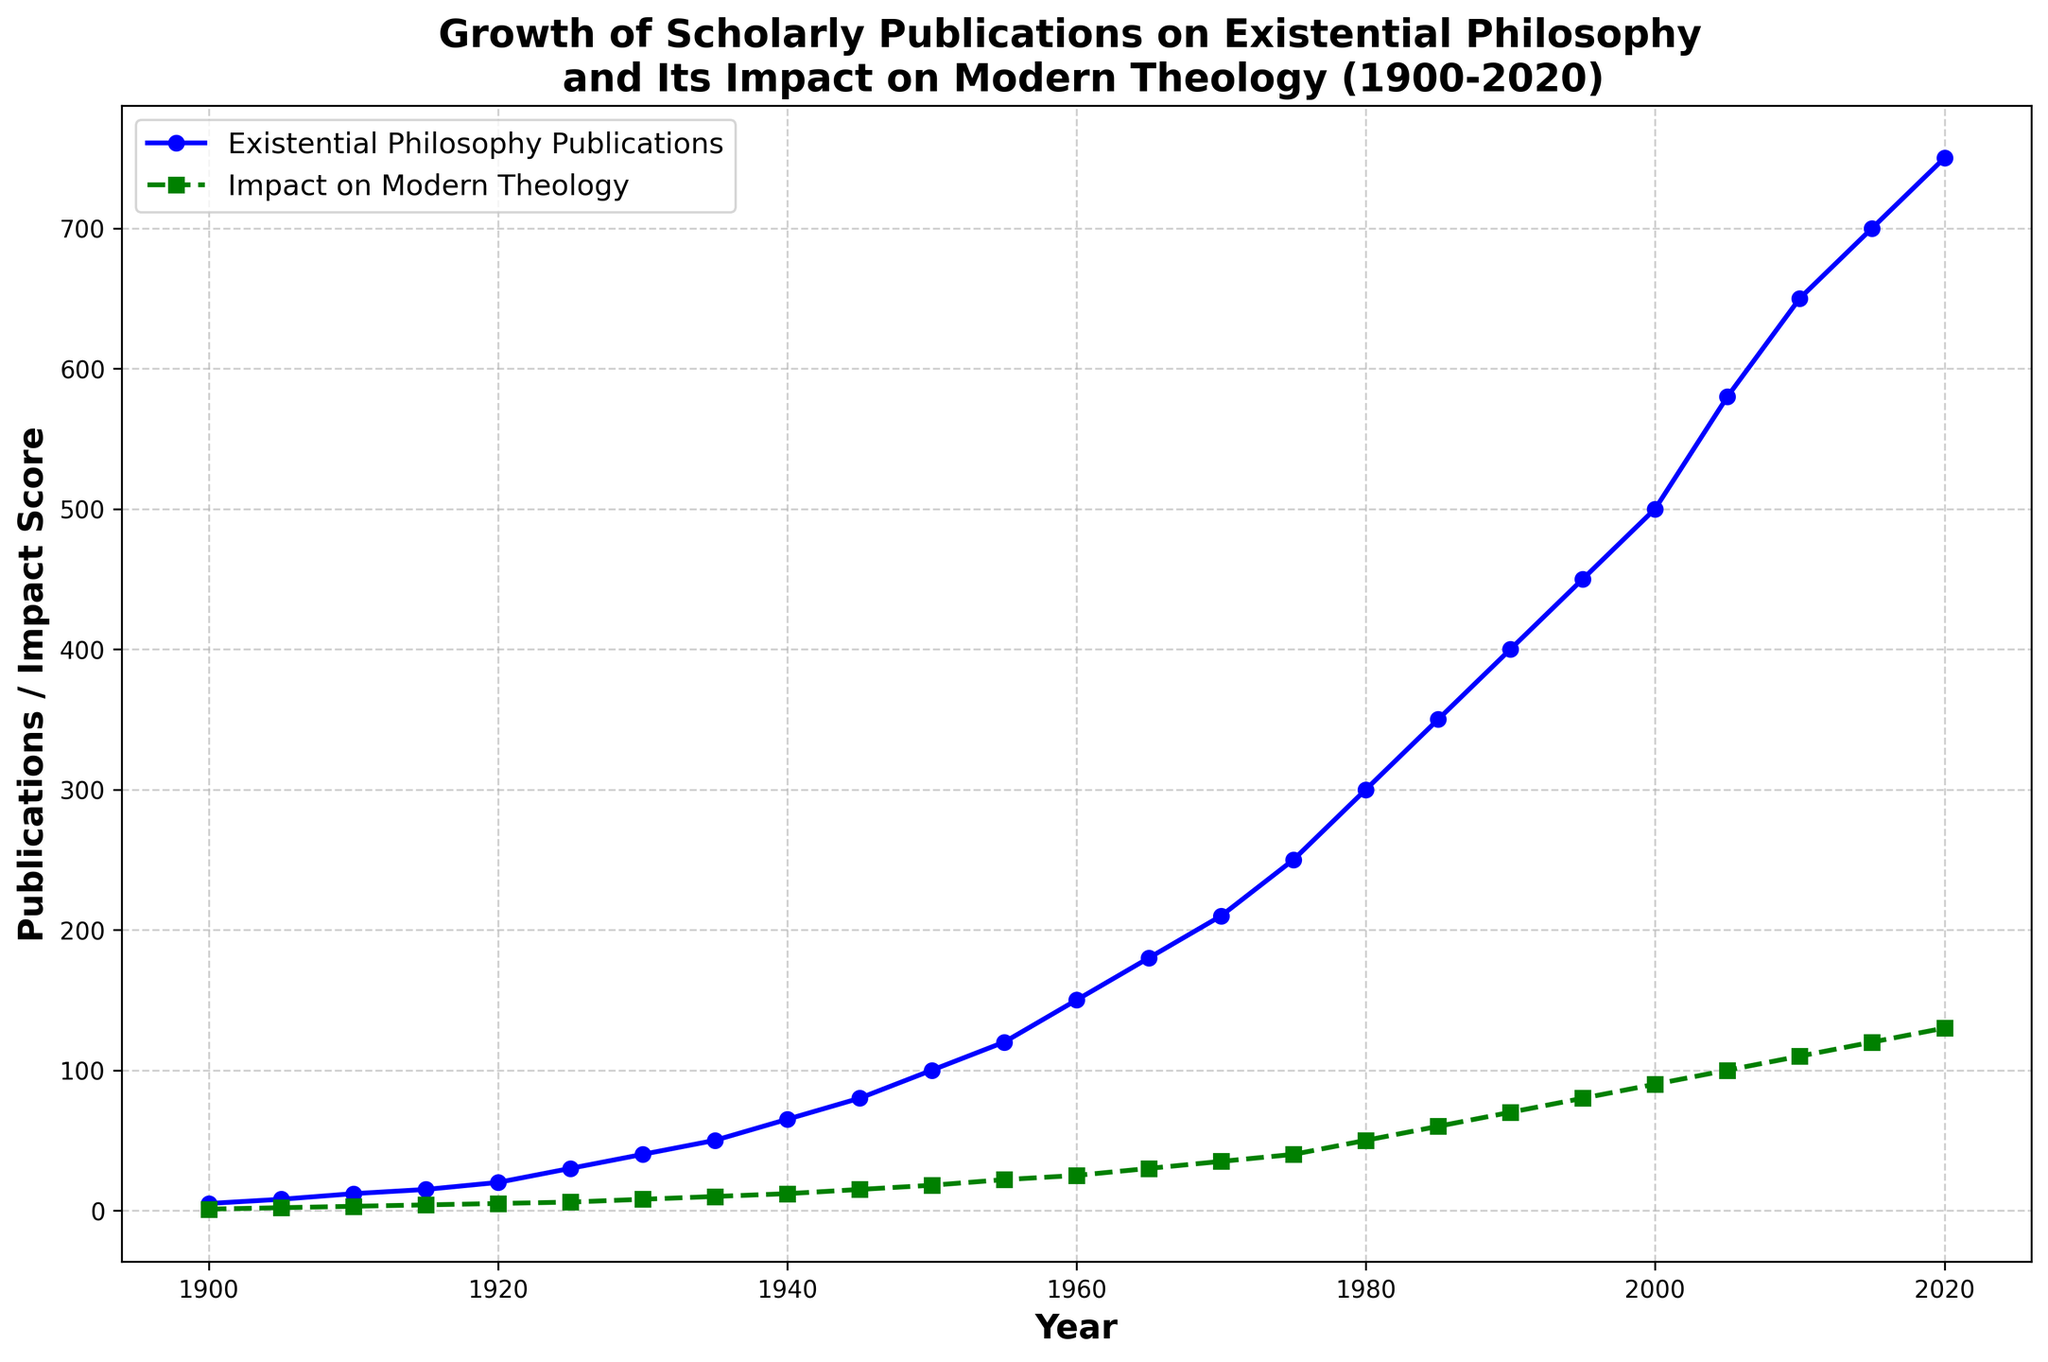What year shows the greatest increase in Existential Philosophy Publications compared to the previous year? To find the year with the greatest increase, calculate the difference in Existential Philosophy Publications for each consecutive year and identify the maximum difference. Notably, the transition between 2000 and 2005 sees an increase from 500 to 580 publications, a rise of 80 publications.
Answer: 2005 In what year did the Impact on Modern Theology exceed 100 for the first time? To determine when the Impact on Modern Theology score first exceeds 100, inspect the values year-by-year. The score surpasses 100 in 2005 with a score of 100 and then goes beyond in 2010 with 110.
Answer: 2010 How many Existential Philosophy Publications were there in 1950 compared to 1930? Compare the values for the Existential Philosophy Publications in these years. In 1950, there were 100 publications, and in 1930, there were 40 publications, indicating an increase of 60.
Answer: 60 more in 1950 Between what years did the Impact on Modern Theology double for the first time? Identify the first interval where the Impact on Modern Theology doubled. From 1950 to 1965, it increased from 18 to 30, nearly doubling. However, from 1960 to 1970, it increased significantly from 25 to 35, meaning the doubling occurred between 1955 (22) and 1965 (30).
Answer: 1955 to 1965 What is the overall trend for Scholarly Publications on Existential Philosophy and its Impact on Modern Theology from 1900 to 2020? Examine the line trends: Scholarly Publications on Existential Philosophy consistently increase, dramatically rising especially post-1960. Similarly, the Impact on Modern Theology shows a gradual increase with notable acceleration after 1940. Both datasets demonstrate an overall escalating trend.
Answer: Both increase By how much did the Impact on Modern Theology grow between 1980 and 2020? To determine the growth, subtract the Impact on Modern Theology score in 1980 (50) from the score in 2020 (130). The calculated difference is 80.
Answer: 80 Which line, representing Existential Philosophy Publications or Impact on Modern Theology, shows a more rapid rise between 1900 and 1950? Compare the slopes: Existential Philosophy Publications rose from 5 to 100, while Impact on Modern Theology increased from 1 to 18. Existential Philosophy Publications had a more significant rise.
Answer: Existential Philosophy Publications What is the ratio of Existential Philosophy Publications to Impact on Modern Theology in 2020? Divide the number of Existential Philosophy Publications (750) by the Impact on Modern Theology score (130) for the year 2020. The ratio is approximately 5.77.
Answer: ~ 5.77 